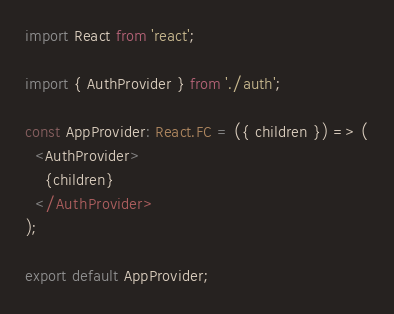<code> <loc_0><loc_0><loc_500><loc_500><_TypeScript_>import React from 'react';

import { AuthProvider } from './auth';

const AppProvider: React.FC = ({ children }) => (
  <AuthProvider>
    {children}
  </AuthProvider>
);

export default AppProvider;</code> 